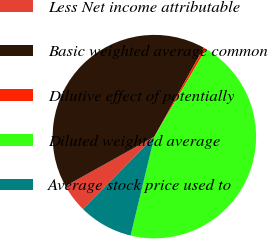<chart> <loc_0><loc_0><loc_500><loc_500><pie_chart><fcel>Less Net income attributable<fcel>Basic weighted average common<fcel>Dilutive effect of potentially<fcel>Diluted weighted average<fcel>Average stock price used to<nl><fcel>4.52%<fcel>41.16%<fcel>0.41%<fcel>45.27%<fcel>8.64%<nl></chart> 